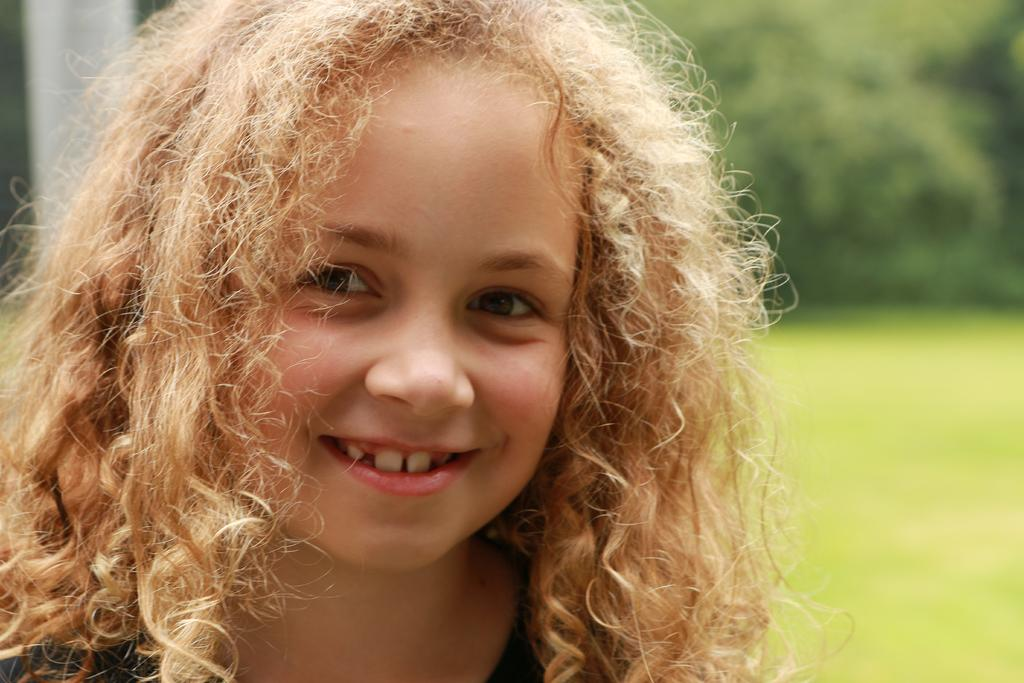Who is the main subject in the image? There is a girl in the image. What is the girl doing in the image? The girl is smiling. What color is predominant in the background of the image? The background of the image has a green color. How would you describe the quality of the image? The image is slightly blurry in the background. How many horses are present in the image? There are no horses present in the image; it features a girl in the foreground. What type of error can be seen in the image? There is no error present in the image; it is a clear photograph of a girl. 